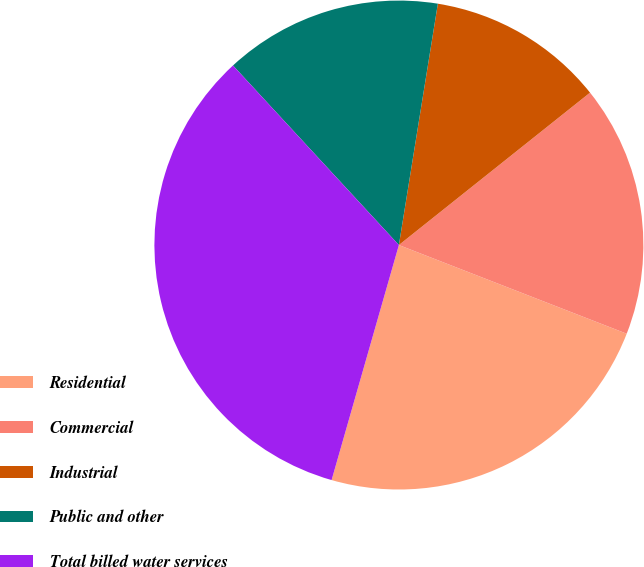Convert chart. <chart><loc_0><loc_0><loc_500><loc_500><pie_chart><fcel>Residential<fcel>Commercial<fcel>Industrial<fcel>Public and other<fcel>Total billed water services<nl><fcel>23.53%<fcel>16.62%<fcel>11.74%<fcel>14.42%<fcel>33.69%<nl></chart> 